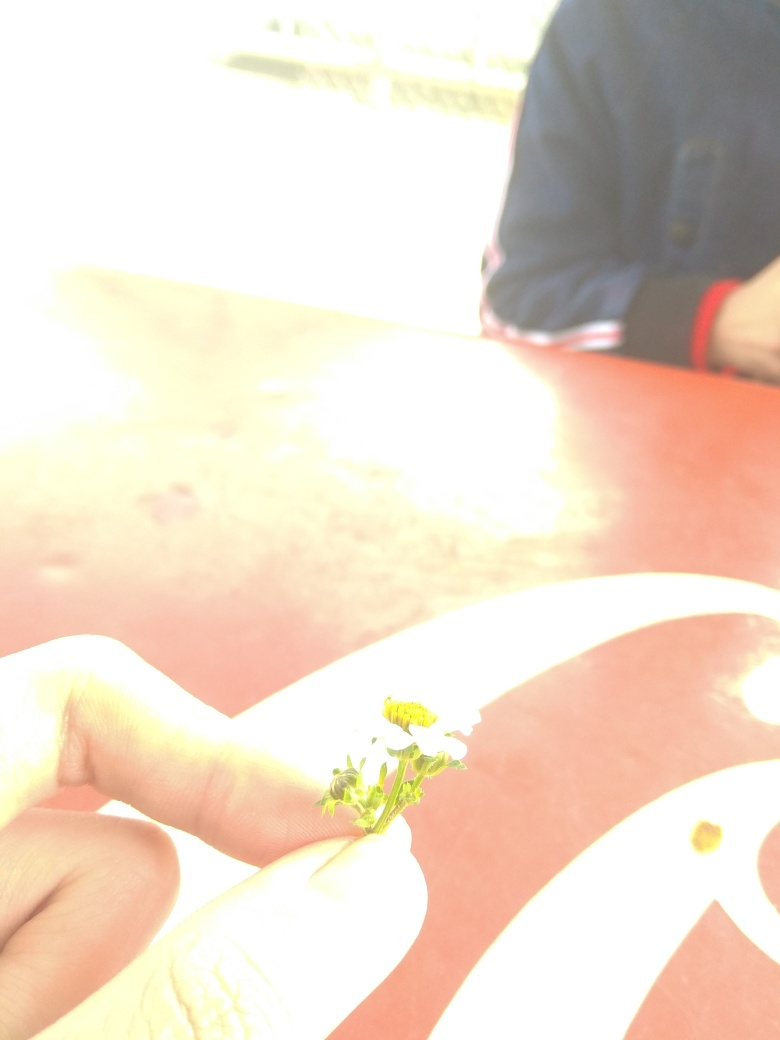Can you describe the main subject in this image? Certainly. The main subject appears to be a person's hand gently holding a small white flower, with the focus on the interaction between the individual and a piece of nature. The background is overexposed, making it difficult to discern additional details, but the central theme is clear — a moment of appreciation for a simple, yet beautiful part of the natural world. 